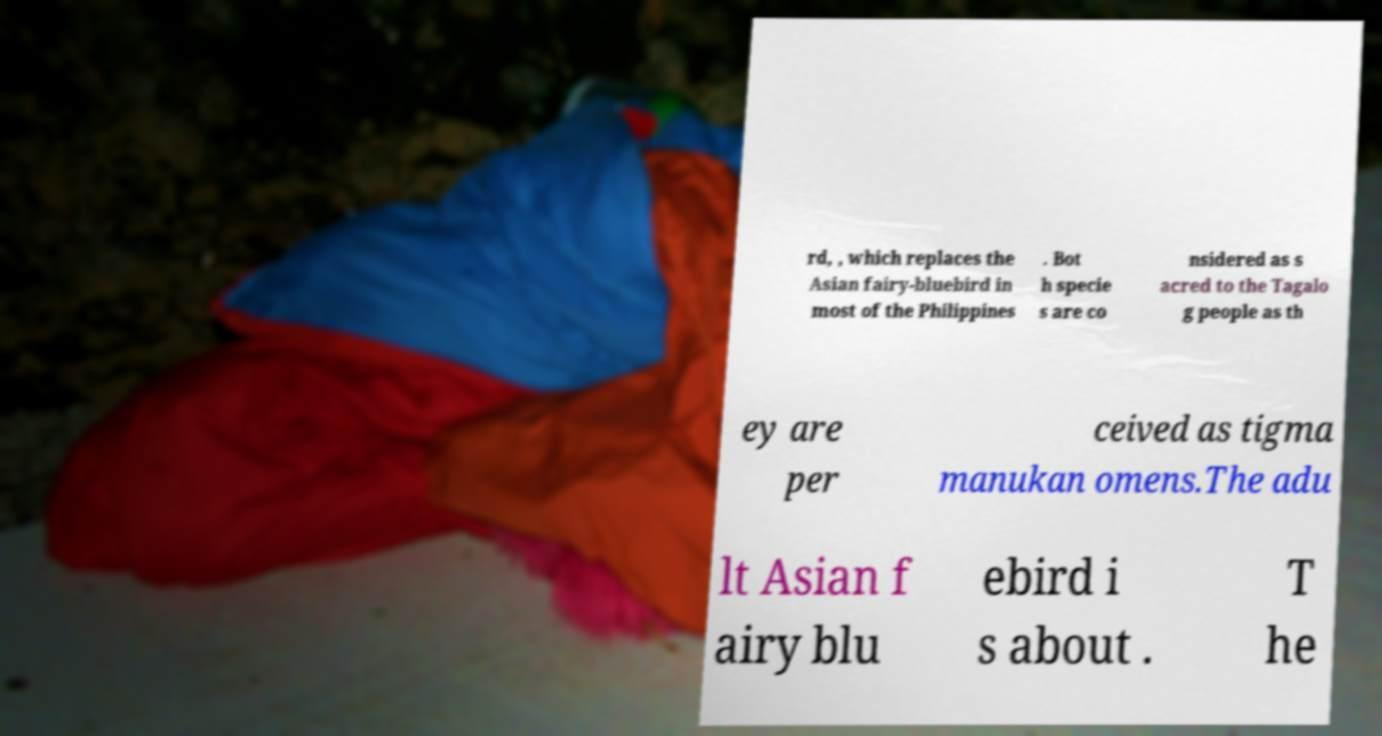Can you accurately transcribe the text from the provided image for me? rd, , which replaces the Asian fairy-bluebird in most of the Philippines . Bot h specie s are co nsidered as s acred to the Tagalo g people as th ey are per ceived as tigma manukan omens.The adu lt Asian f airy blu ebird i s about . T he 